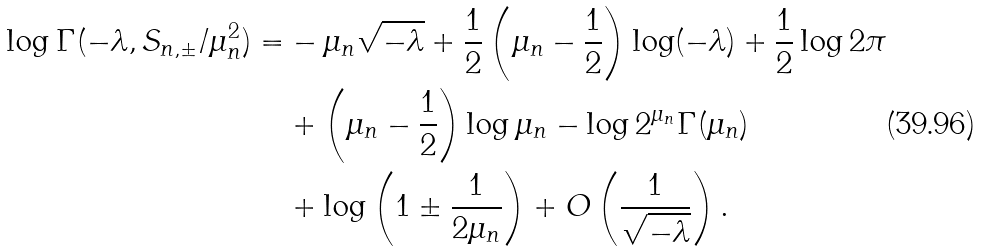Convert formula to latex. <formula><loc_0><loc_0><loc_500><loc_500>\log \Gamma ( - \lambda , S _ { n , \pm } / \mu _ { n } ^ { 2 } ) = & - \mu _ { n } \sqrt { - \lambda } + \frac { 1 } { 2 } \left ( \mu _ { n } - \frac { 1 } { 2 } \right ) \log ( - \lambda ) + \frac { 1 } { 2 } \log 2 \pi \\ & + \left ( \mu _ { n } - \frac { 1 } { 2 } \right ) \log \mu _ { n } - \log 2 ^ { \mu _ { n } } \Gamma ( \mu _ { n } ) \\ & + \log \left ( 1 \pm \frac { 1 } { 2 \mu _ { n } } \right ) + O \left ( \frac { 1 } { \sqrt { - \lambda } } \right ) .</formula> 